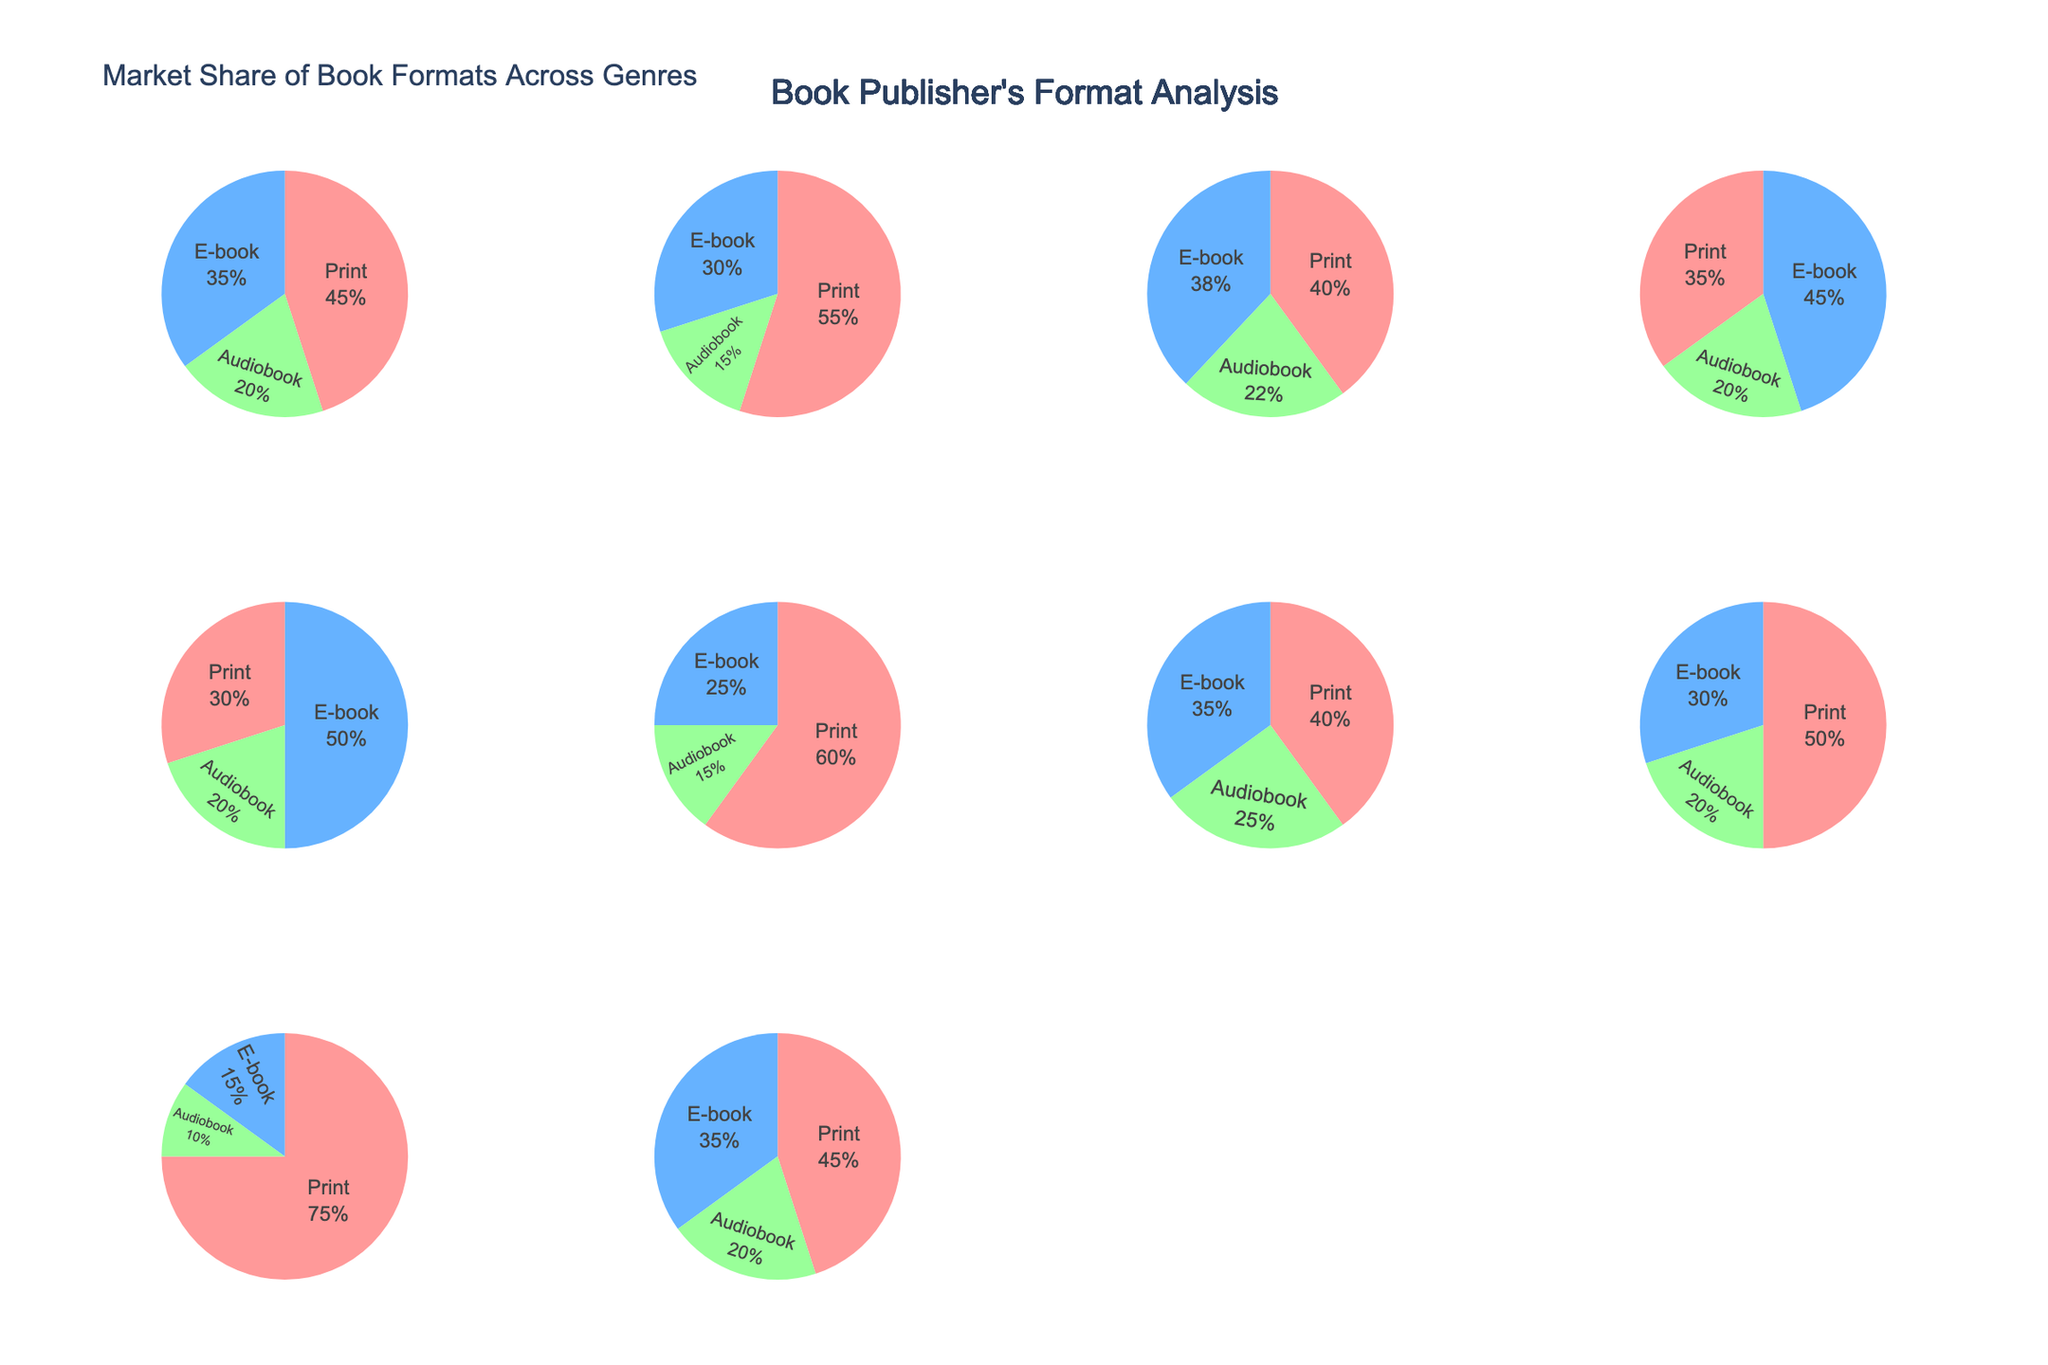What's the title of the figure? The title of the figure is displayed at the top and reads "Market Share of Book Formats Across Genres."
Answer: Market Share of Book Formats Across Genres Which genre has the highest market share for print books? By observing the pie charts, Children's Books has the largest portion dedicated to print books.
Answer: Children's Books In which genre is the market share for e-books greater than print books? The segments for e-books are larger than those for print books in the Romance and Science Fiction genres.
Answer: Romance and Science Fiction Which genre has an equal market share for audiobooks and e-books? By comparing the pie segments, there is no genre where audiobooks and e-books have exactly equal market shares.
Answer: None What is the market share of audiobooks in the Young Adult genre? Analyzing the Young Adult pie chart, the segment marked for audiobooks corresponds to 20%.
Answer: 20% Which two genres have the closest market share for audiobooks? The Audiobook segments for Mystery/Thriller and Romance both show 20%, indicating they are the closest.
Answer: Mystery/Thriller and Romance Summing up the market shares for print and audiobooks, which genre has the highest combined share? Adding the percentages for Print and Audiobooks, Children's Books have the highest combined share (75% + 10% = 85%).
Answer: Children's Books Which genre has the smallest market share for e-books? The segment for e-books in Children's Books is smaller than in all other genres, visible at 15%.
Answer: Children's Books How does the market share of print books in Business compare to Non-fiction? The print book segments for Business and Non-fiction are 45% and 55% respectively, showing Non-fiction has a higher share.
Answer: Non-fiction Which genre features a higher market share for audiobooks, Self-help or Biography? By comparing the slices, the Self-help genre has 25% while Biography has 15%, indicating Self-help has a higher share.
Answer: Self-help 